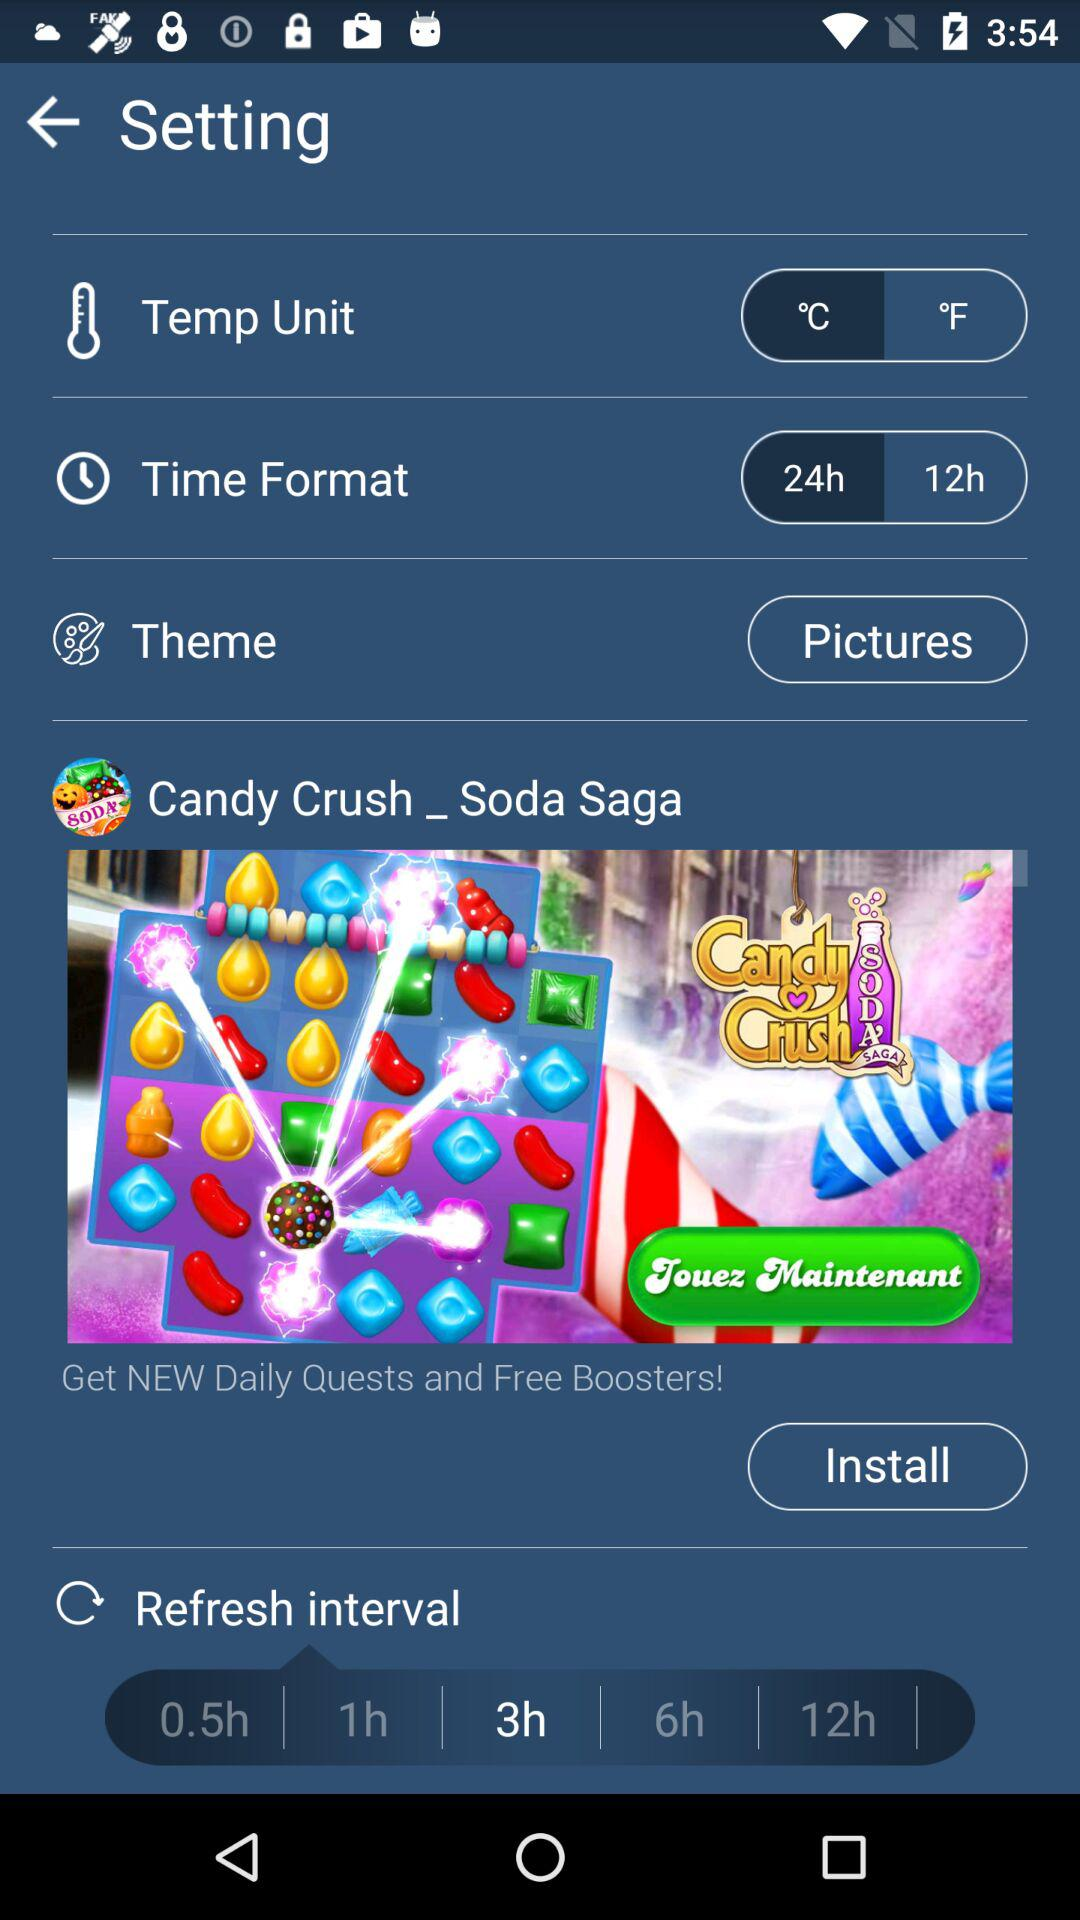What theme is selected? The selected theme is "Pictures". 